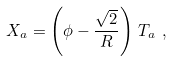<formula> <loc_0><loc_0><loc_500><loc_500>X _ { a } = \left ( \phi - \frac { \sqrt { 2 } } { R } \right ) \, T _ { a } \ ,</formula> 